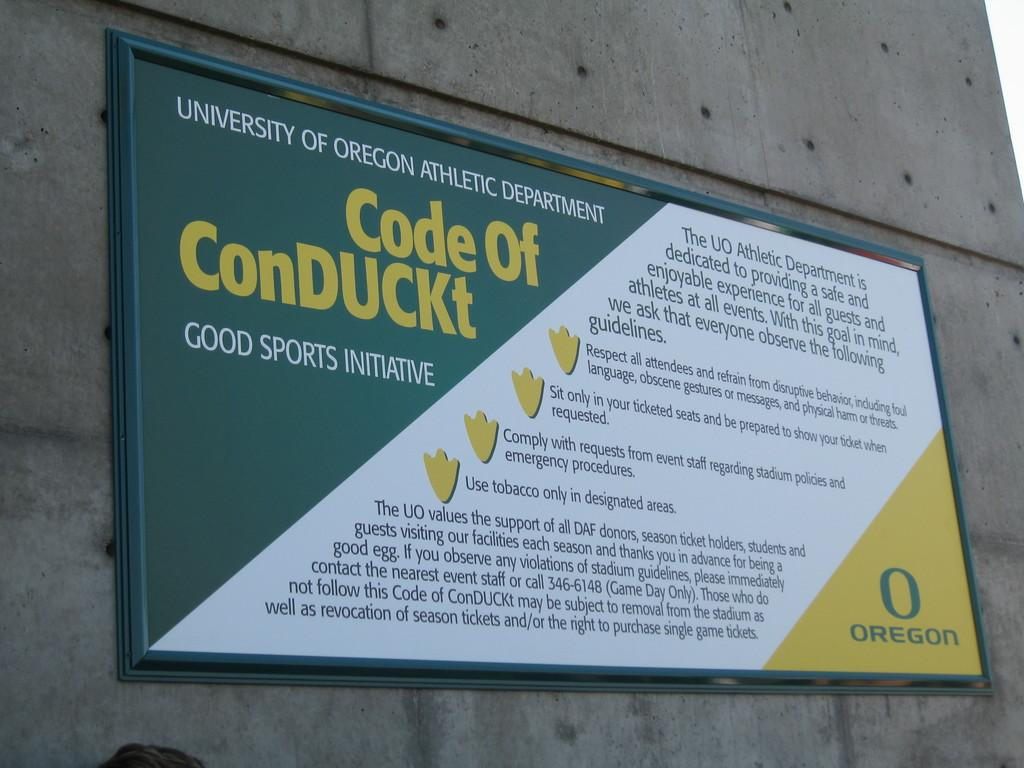<image>
Provide a brief description of the given image. A sign titled Code Of ConDUCKt from University of Oregon athletic department 